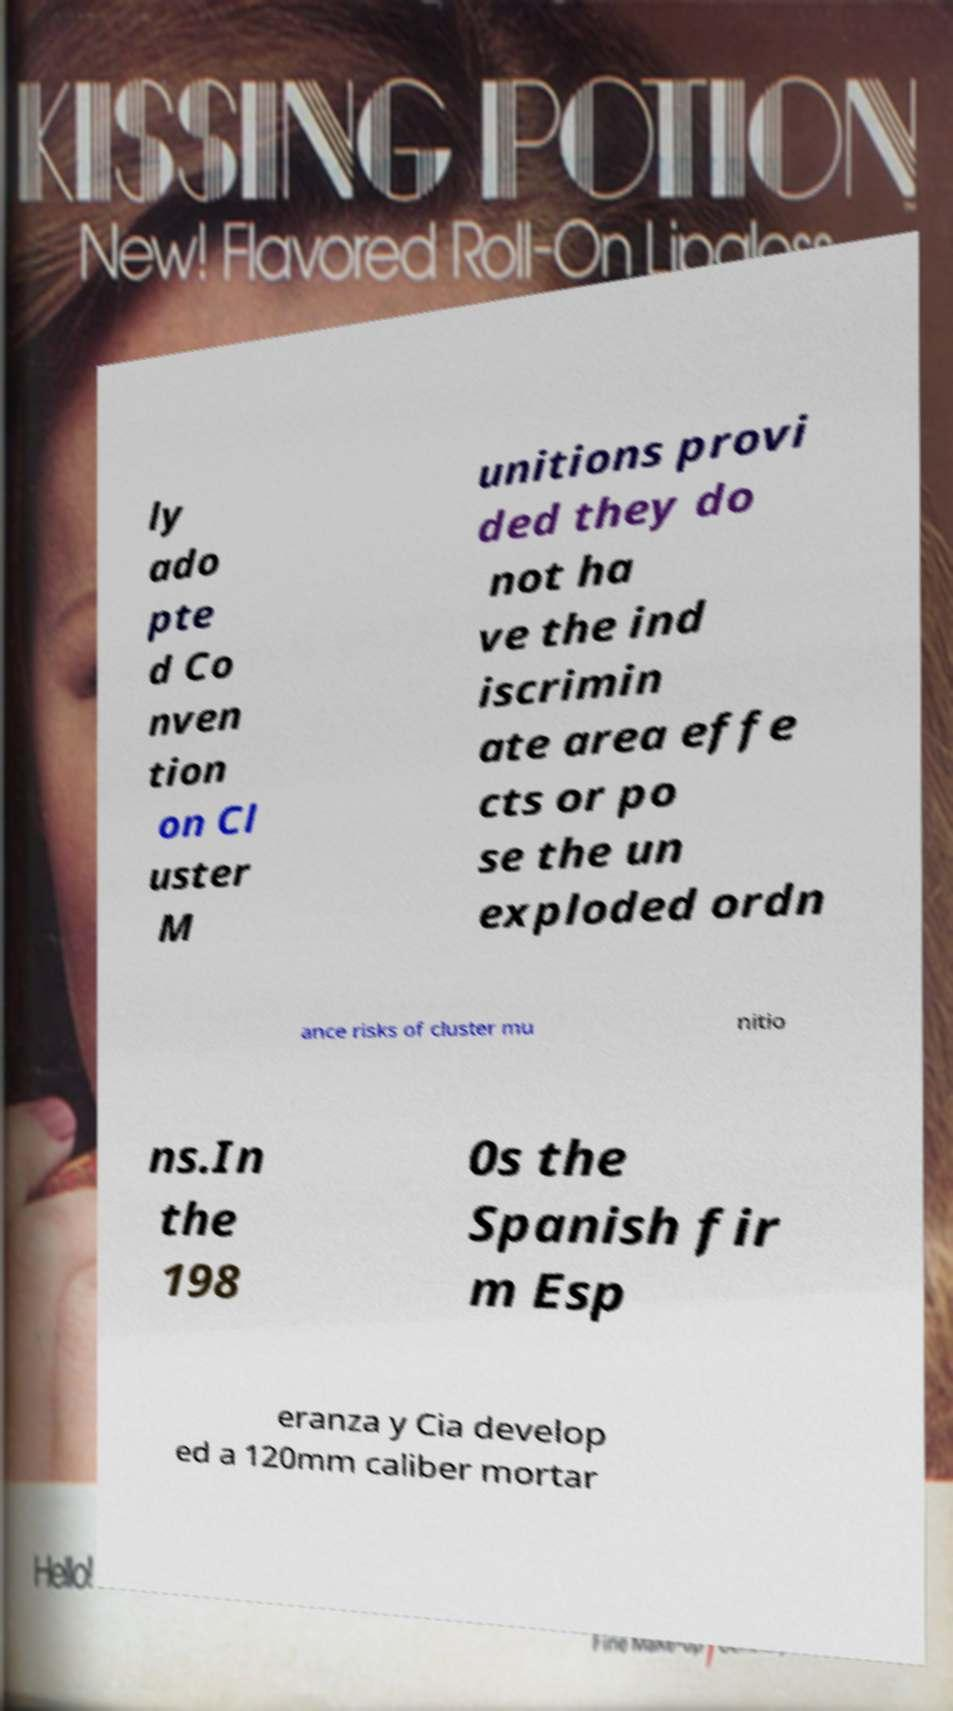For documentation purposes, I need the text within this image transcribed. Could you provide that? ly ado pte d Co nven tion on Cl uster M unitions provi ded they do not ha ve the ind iscrimin ate area effe cts or po se the un exploded ordn ance risks of cluster mu nitio ns.In the 198 0s the Spanish fir m Esp eranza y Cia develop ed a 120mm caliber mortar 